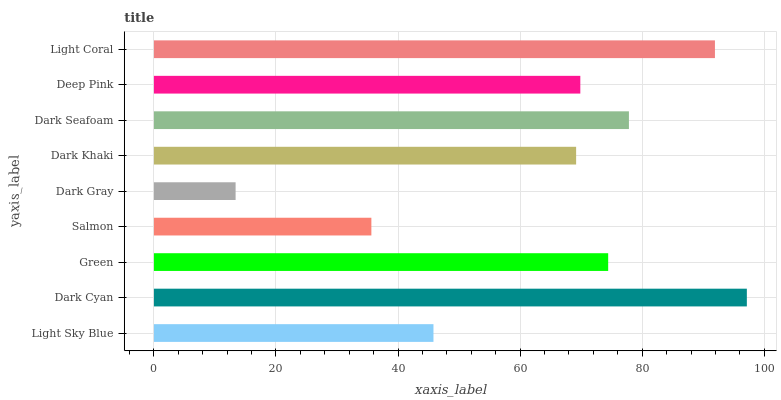Is Dark Gray the minimum?
Answer yes or no. Yes. Is Dark Cyan the maximum?
Answer yes or no. Yes. Is Green the minimum?
Answer yes or no. No. Is Green the maximum?
Answer yes or no. No. Is Dark Cyan greater than Green?
Answer yes or no. Yes. Is Green less than Dark Cyan?
Answer yes or no. Yes. Is Green greater than Dark Cyan?
Answer yes or no. No. Is Dark Cyan less than Green?
Answer yes or no. No. Is Deep Pink the high median?
Answer yes or no. Yes. Is Deep Pink the low median?
Answer yes or no. Yes. Is Dark Gray the high median?
Answer yes or no. No. Is Dark Gray the low median?
Answer yes or no. No. 